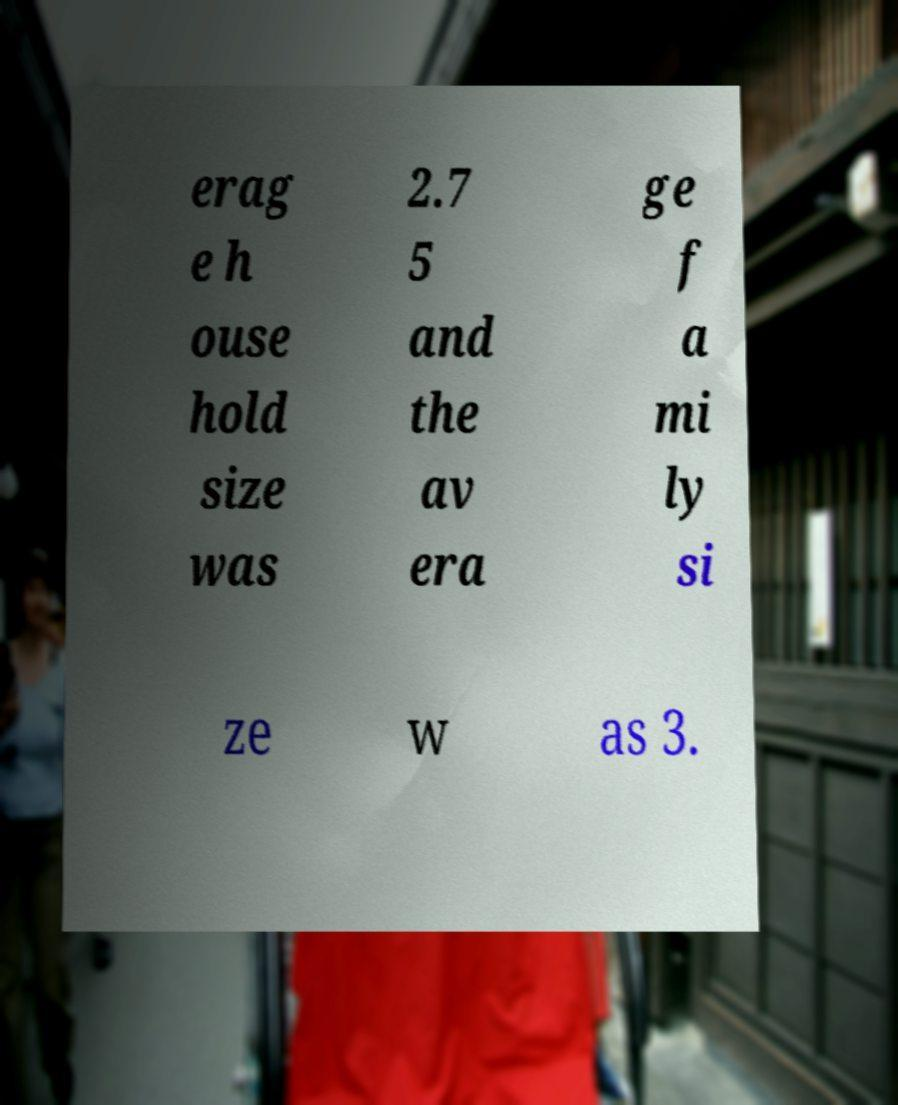For documentation purposes, I need the text within this image transcribed. Could you provide that? erag e h ouse hold size was 2.7 5 and the av era ge f a mi ly si ze w as 3. 